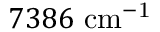<formula> <loc_0><loc_0><loc_500><loc_500>7 3 8 6 c m ^ { - 1 }</formula> 